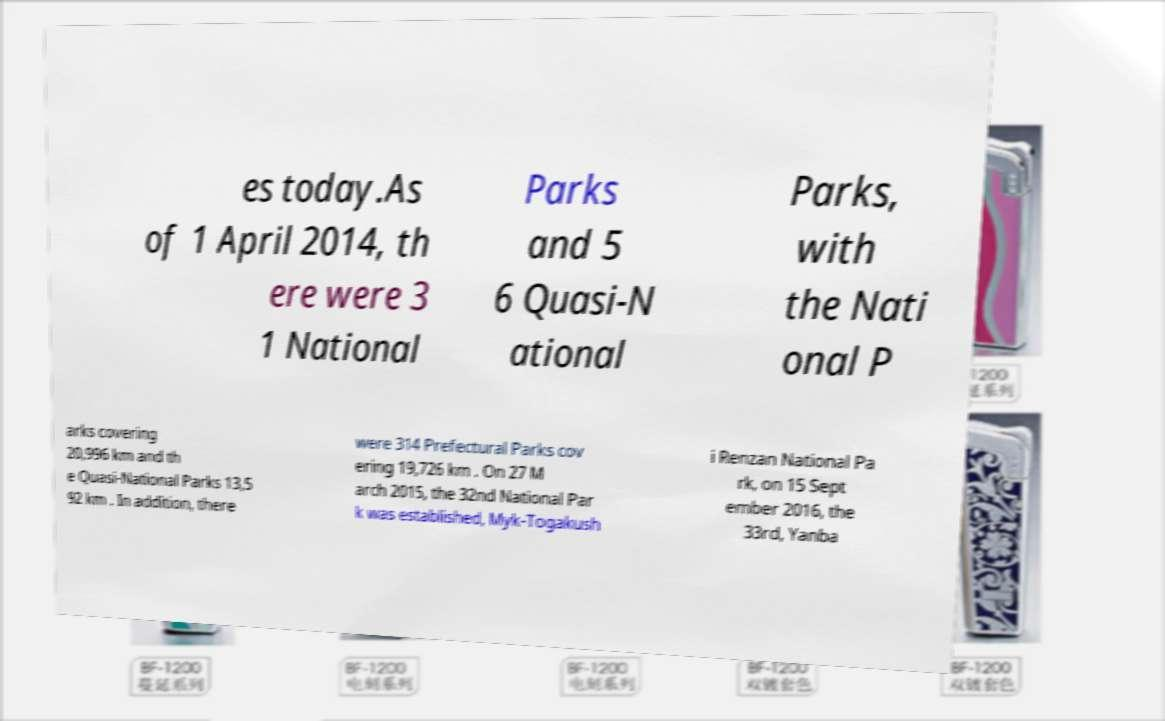There's text embedded in this image that I need extracted. Can you transcribe it verbatim? es today.As of 1 April 2014, th ere were 3 1 National Parks and 5 6 Quasi-N ational Parks, with the Nati onal P arks covering 20,996 km and th e Quasi-National Parks 13,5 92 km . In addition, there were 314 Prefectural Parks cov ering 19,726 km . On 27 M arch 2015, the 32nd National Par k was established, Myk-Togakush i Renzan National Pa rk, on 15 Sept ember 2016, the 33rd, Yanba 